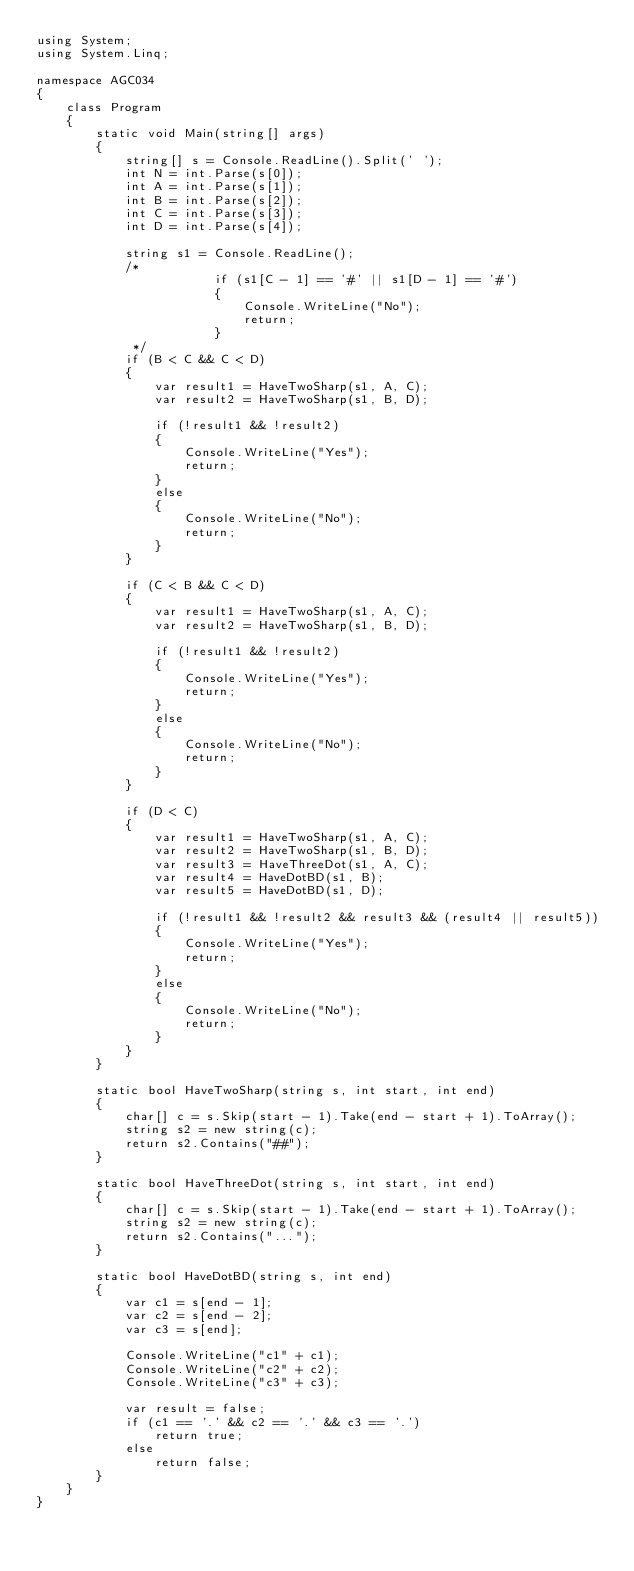Convert code to text. <code><loc_0><loc_0><loc_500><loc_500><_C#_>using System;
using System.Linq;

namespace AGC034
{
    class Program
    {
        static void Main(string[] args)
        {
            string[] s = Console.ReadLine().Split(' ');
            int N = int.Parse(s[0]);
            int A = int.Parse(s[1]);
            int B = int.Parse(s[2]);
            int C = int.Parse(s[3]);
            int D = int.Parse(s[4]);

            string s1 = Console.ReadLine();
            /*
                        if (s1[C - 1] == '#' || s1[D - 1] == '#')
                        {
                            Console.WriteLine("No");
                            return;
                        }
             */
            if (B < C && C < D)
            {
                var result1 = HaveTwoSharp(s1, A, C);
                var result2 = HaveTwoSharp(s1, B, D);

                if (!result1 && !result2)
                {
                    Console.WriteLine("Yes");
                    return;
                }
                else
                {
                    Console.WriteLine("No");
                    return;
                }
            }

            if (C < B && C < D)
            {
                var result1 = HaveTwoSharp(s1, A, C);
                var result2 = HaveTwoSharp(s1, B, D);

                if (!result1 && !result2)
                {
                    Console.WriteLine("Yes");
                    return;
                }
                else
                {
                    Console.WriteLine("No");
                    return;
                }
            }

            if (D < C)
            {
                var result1 = HaveTwoSharp(s1, A, C);
                var result2 = HaveTwoSharp(s1, B, D);
                var result3 = HaveThreeDot(s1, A, C);
                var result4 = HaveDotBD(s1, B);
                var result5 = HaveDotBD(s1, D);

                if (!result1 && !result2 && result3 && (result4 || result5))
                {
                    Console.WriteLine("Yes");
                    return;
                }
                else
                {
                    Console.WriteLine("No");
                    return;
                }
            }
        }

        static bool HaveTwoSharp(string s, int start, int end)
        {
            char[] c = s.Skip(start - 1).Take(end - start + 1).ToArray();
            string s2 = new string(c);
            return s2.Contains("##");
        }

        static bool HaveThreeDot(string s, int start, int end)
        {
            char[] c = s.Skip(start - 1).Take(end - start + 1).ToArray();
            string s2 = new string(c);
            return s2.Contains("...");
        }

        static bool HaveDotBD(string s, int end)
        {
            var c1 = s[end - 1];
            var c2 = s[end - 2];
            var c3 = s[end];

            Console.WriteLine("c1" + c1);
            Console.WriteLine("c2" + c2);
            Console.WriteLine("c3" + c3);

            var result = false;
            if (c1 == '.' && c2 == '.' && c3 == '.')
                return true;
            else
                return false;
        }
    }
}</code> 